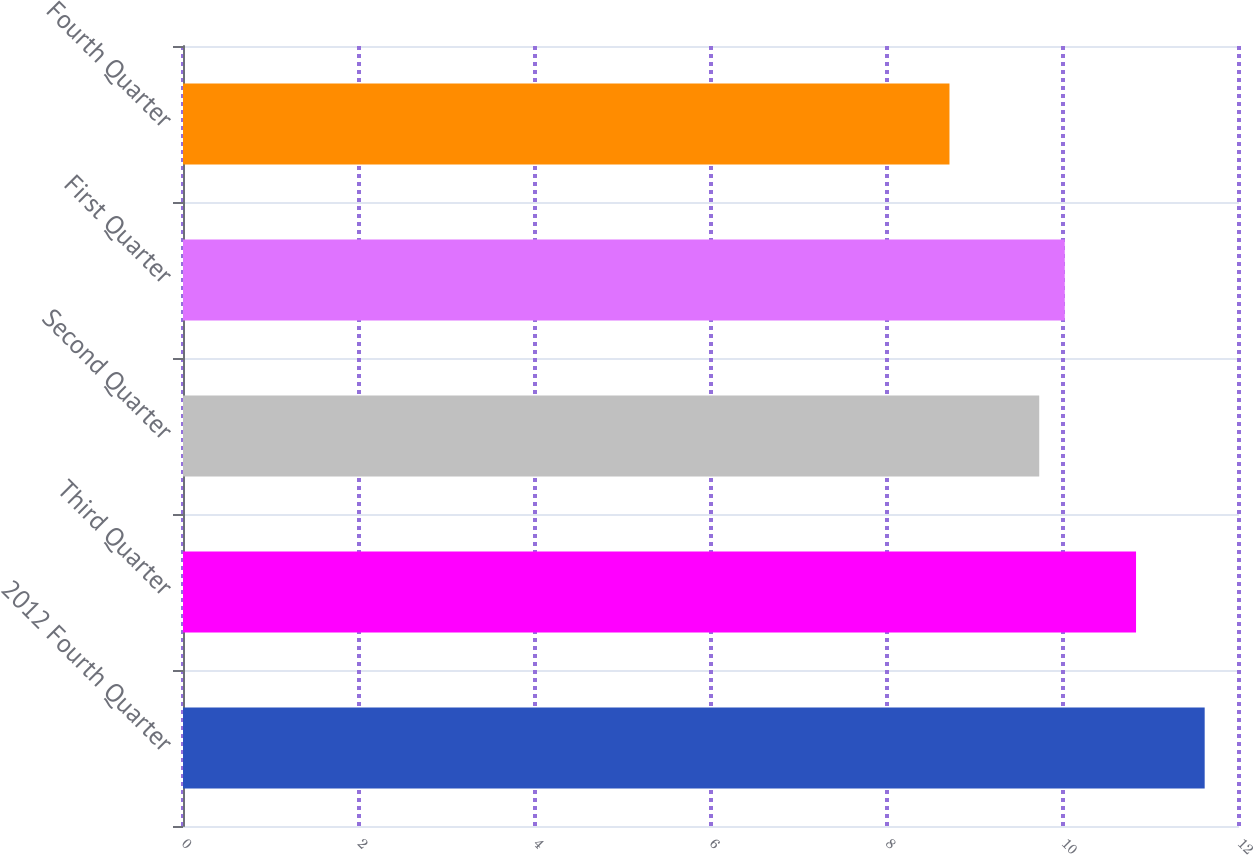Convert chart. <chart><loc_0><loc_0><loc_500><loc_500><bar_chart><fcel>2012 Fourth Quarter<fcel>Third Quarter<fcel>Second Quarter<fcel>First Quarter<fcel>Fourth Quarter<nl><fcel>11.61<fcel>10.83<fcel>9.73<fcel>10.02<fcel>8.71<nl></chart> 